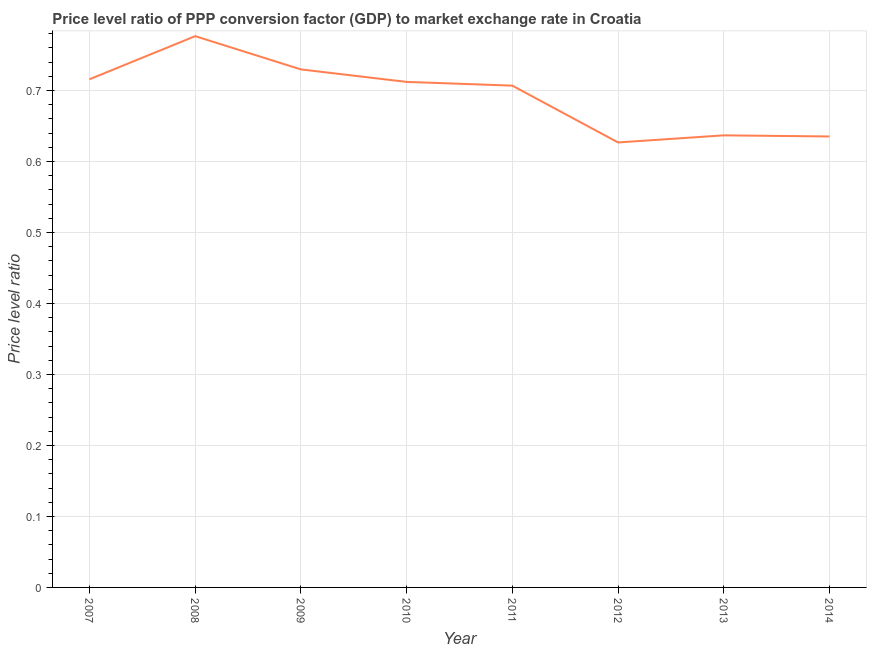What is the price level ratio in 2011?
Make the answer very short. 0.71. Across all years, what is the maximum price level ratio?
Provide a short and direct response. 0.78. Across all years, what is the minimum price level ratio?
Offer a very short reply. 0.63. In which year was the price level ratio maximum?
Your answer should be very brief. 2008. In which year was the price level ratio minimum?
Keep it short and to the point. 2012. What is the sum of the price level ratio?
Your answer should be very brief. 5.54. What is the difference between the price level ratio in 2009 and 2014?
Provide a succinct answer. 0.09. What is the average price level ratio per year?
Give a very brief answer. 0.69. What is the median price level ratio?
Your answer should be compact. 0.71. Do a majority of the years between 2007 and 2008 (inclusive) have price level ratio greater than 0.06 ?
Provide a succinct answer. Yes. What is the ratio of the price level ratio in 2009 to that in 2011?
Ensure brevity in your answer.  1.03. Is the price level ratio in 2010 less than that in 2012?
Offer a very short reply. No. What is the difference between the highest and the second highest price level ratio?
Ensure brevity in your answer.  0.05. What is the difference between the highest and the lowest price level ratio?
Keep it short and to the point. 0.15. In how many years, is the price level ratio greater than the average price level ratio taken over all years?
Your answer should be compact. 5. Does the price level ratio monotonically increase over the years?
Your response must be concise. No. How many years are there in the graph?
Give a very brief answer. 8. What is the difference between two consecutive major ticks on the Y-axis?
Make the answer very short. 0.1. Are the values on the major ticks of Y-axis written in scientific E-notation?
Provide a short and direct response. No. Does the graph contain any zero values?
Keep it short and to the point. No. What is the title of the graph?
Give a very brief answer. Price level ratio of PPP conversion factor (GDP) to market exchange rate in Croatia. What is the label or title of the X-axis?
Provide a short and direct response. Year. What is the label or title of the Y-axis?
Provide a succinct answer. Price level ratio. What is the Price level ratio in 2007?
Ensure brevity in your answer.  0.72. What is the Price level ratio of 2008?
Your response must be concise. 0.78. What is the Price level ratio of 2009?
Provide a short and direct response. 0.73. What is the Price level ratio of 2010?
Your response must be concise. 0.71. What is the Price level ratio in 2011?
Give a very brief answer. 0.71. What is the Price level ratio of 2012?
Make the answer very short. 0.63. What is the Price level ratio in 2013?
Offer a terse response. 0.64. What is the Price level ratio of 2014?
Provide a succinct answer. 0.64. What is the difference between the Price level ratio in 2007 and 2008?
Your response must be concise. -0.06. What is the difference between the Price level ratio in 2007 and 2009?
Your answer should be very brief. -0.01. What is the difference between the Price level ratio in 2007 and 2010?
Your response must be concise. 0. What is the difference between the Price level ratio in 2007 and 2011?
Offer a very short reply. 0.01. What is the difference between the Price level ratio in 2007 and 2012?
Provide a short and direct response. 0.09. What is the difference between the Price level ratio in 2007 and 2013?
Your response must be concise. 0.08. What is the difference between the Price level ratio in 2007 and 2014?
Ensure brevity in your answer.  0.08. What is the difference between the Price level ratio in 2008 and 2009?
Your answer should be compact. 0.05. What is the difference between the Price level ratio in 2008 and 2010?
Provide a short and direct response. 0.06. What is the difference between the Price level ratio in 2008 and 2011?
Your answer should be very brief. 0.07. What is the difference between the Price level ratio in 2008 and 2012?
Offer a very short reply. 0.15. What is the difference between the Price level ratio in 2008 and 2013?
Ensure brevity in your answer.  0.14. What is the difference between the Price level ratio in 2008 and 2014?
Make the answer very short. 0.14. What is the difference between the Price level ratio in 2009 and 2010?
Offer a terse response. 0.02. What is the difference between the Price level ratio in 2009 and 2011?
Offer a terse response. 0.02. What is the difference between the Price level ratio in 2009 and 2012?
Provide a succinct answer. 0.1. What is the difference between the Price level ratio in 2009 and 2013?
Keep it short and to the point. 0.09. What is the difference between the Price level ratio in 2009 and 2014?
Your answer should be very brief. 0.09. What is the difference between the Price level ratio in 2010 and 2011?
Offer a very short reply. 0.01. What is the difference between the Price level ratio in 2010 and 2012?
Offer a very short reply. 0.09. What is the difference between the Price level ratio in 2010 and 2013?
Keep it short and to the point. 0.08. What is the difference between the Price level ratio in 2010 and 2014?
Make the answer very short. 0.08. What is the difference between the Price level ratio in 2011 and 2012?
Provide a succinct answer. 0.08. What is the difference between the Price level ratio in 2011 and 2013?
Keep it short and to the point. 0.07. What is the difference between the Price level ratio in 2011 and 2014?
Provide a short and direct response. 0.07. What is the difference between the Price level ratio in 2012 and 2013?
Ensure brevity in your answer.  -0.01. What is the difference between the Price level ratio in 2012 and 2014?
Provide a short and direct response. -0.01. What is the difference between the Price level ratio in 2013 and 2014?
Provide a succinct answer. 0. What is the ratio of the Price level ratio in 2007 to that in 2008?
Your answer should be very brief. 0.92. What is the ratio of the Price level ratio in 2007 to that in 2010?
Offer a very short reply. 1. What is the ratio of the Price level ratio in 2007 to that in 2012?
Your answer should be very brief. 1.14. What is the ratio of the Price level ratio in 2007 to that in 2013?
Your answer should be very brief. 1.12. What is the ratio of the Price level ratio in 2007 to that in 2014?
Provide a succinct answer. 1.13. What is the ratio of the Price level ratio in 2008 to that in 2009?
Your answer should be very brief. 1.06. What is the ratio of the Price level ratio in 2008 to that in 2010?
Keep it short and to the point. 1.09. What is the ratio of the Price level ratio in 2008 to that in 2011?
Provide a short and direct response. 1.1. What is the ratio of the Price level ratio in 2008 to that in 2012?
Make the answer very short. 1.24. What is the ratio of the Price level ratio in 2008 to that in 2013?
Keep it short and to the point. 1.22. What is the ratio of the Price level ratio in 2008 to that in 2014?
Keep it short and to the point. 1.22. What is the ratio of the Price level ratio in 2009 to that in 2010?
Provide a succinct answer. 1.02. What is the ratio of the Price level ratio in 2009 to that in 2011?
Your answer should be compact. 1.03. What is the ratio of the Price level ratio in 2009 to that in 2012?
Provide a succinct answer. 1.16. What is the ratio of the Price level ratio in 2009 to that in 2013?
Your response must be concise. 1.15. What is the ratio of the Price level ratio in 2009 to that in 2014?
Give a very brief answer. 1.15. What is the ratio of the Price level ratio in 2010 to that in 2012?
Your answer should be very brief. 1.14. What is the ratio of the Price level ratio in 2010 to that in 2013?
Your answer should be compact. 1.12. What is the ratio of the Price level ratio in 2010 to that in 2014?
Your response must be concise. 1.12. What is the ratio of the Price level ratio in 2011 to that in 2012?
Offer a very short reply. 1.13. What is the ratio of the Price level ratio in 2011 to that in 2013?
Your answer should be very brief. 1.11. What is the ratio of the Price level ratio in 2011 to that in 2014?
Offer a terse response. 1.11. What is the ratio of the Price level ratio in 2012 to that in 2013?
Give a very brief answer. 0.98. 